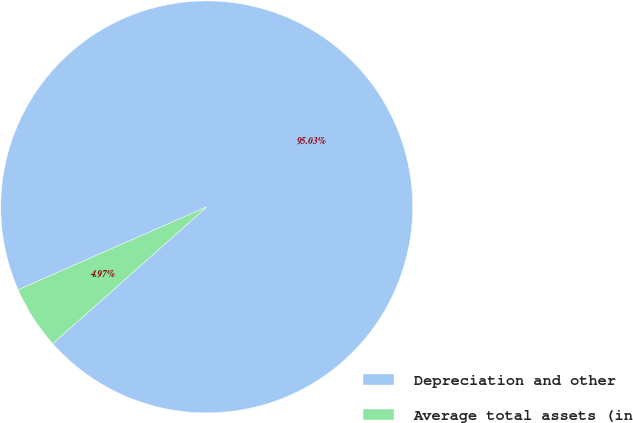Convert chart to OTSL. <chart><loc_0><loc_0><loc_500><loc_500><pie_chart><fcel>Depreciation and other<fcel>Average total assets (in<nl><fcel>95.03%<fcel>4.97%<nl></chart> 